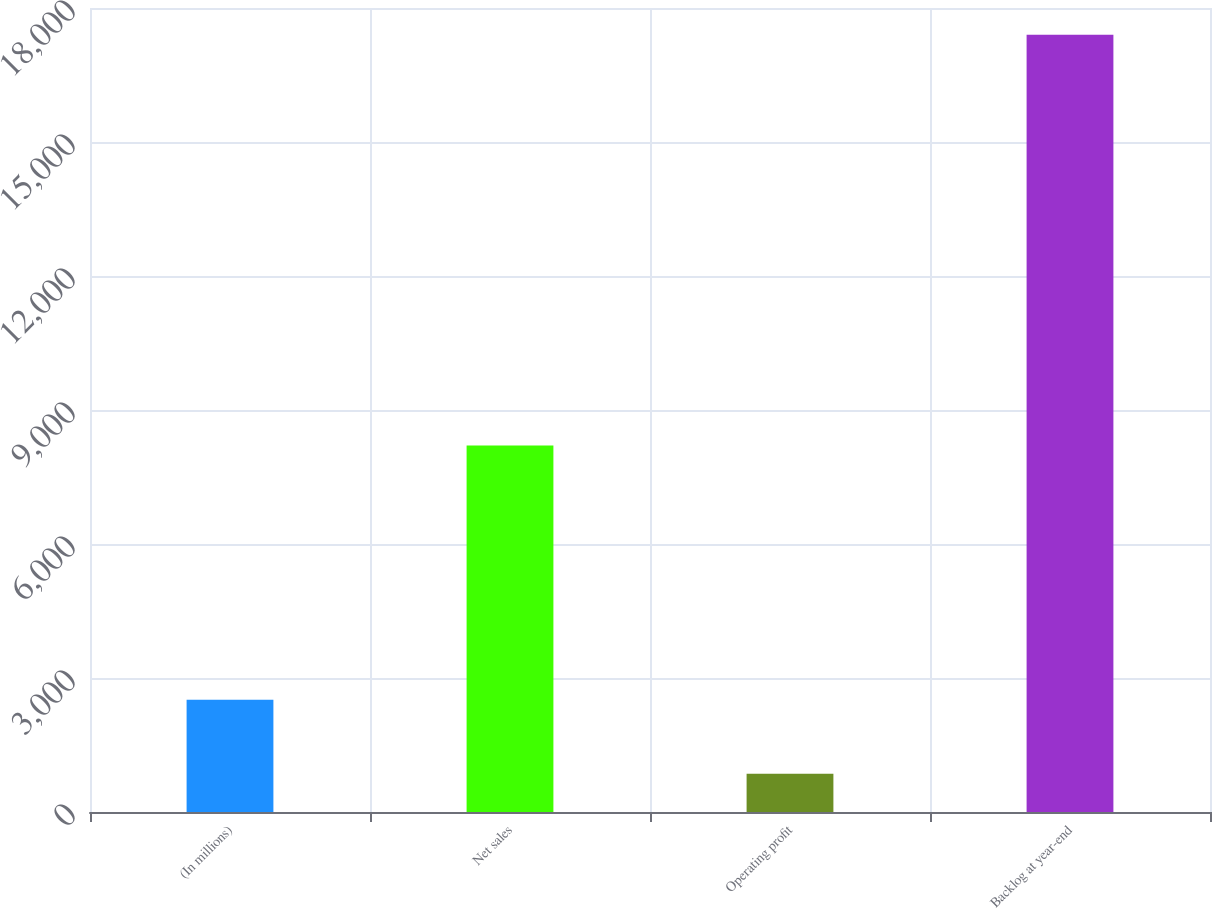Convert chart to OTSL. <chart><loc_0><loc_0><loc_500><loc_500><bar_chart><fcel>(In millions)<fcel>Net sales<fcel>Operating profit<fcel>Backlog at year-end<nl><fcel>2510.4<fcel>8203<fcel>856<fcel>17400<nl></chart> 